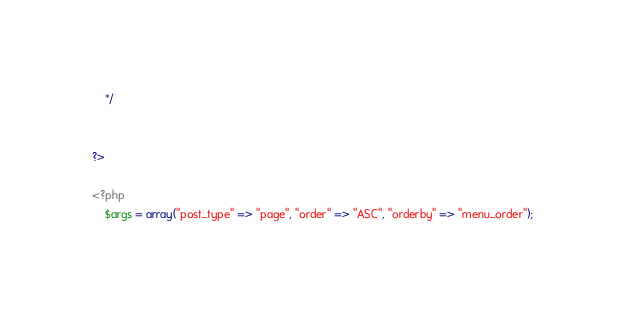<code> <loc_0><loc_0><loc_500><loc_500><_PHP_>    */


?>

<?php
    $args = array("post_type" => "page", "order" => "ASC", "orderby" => "menu_order");</code> 